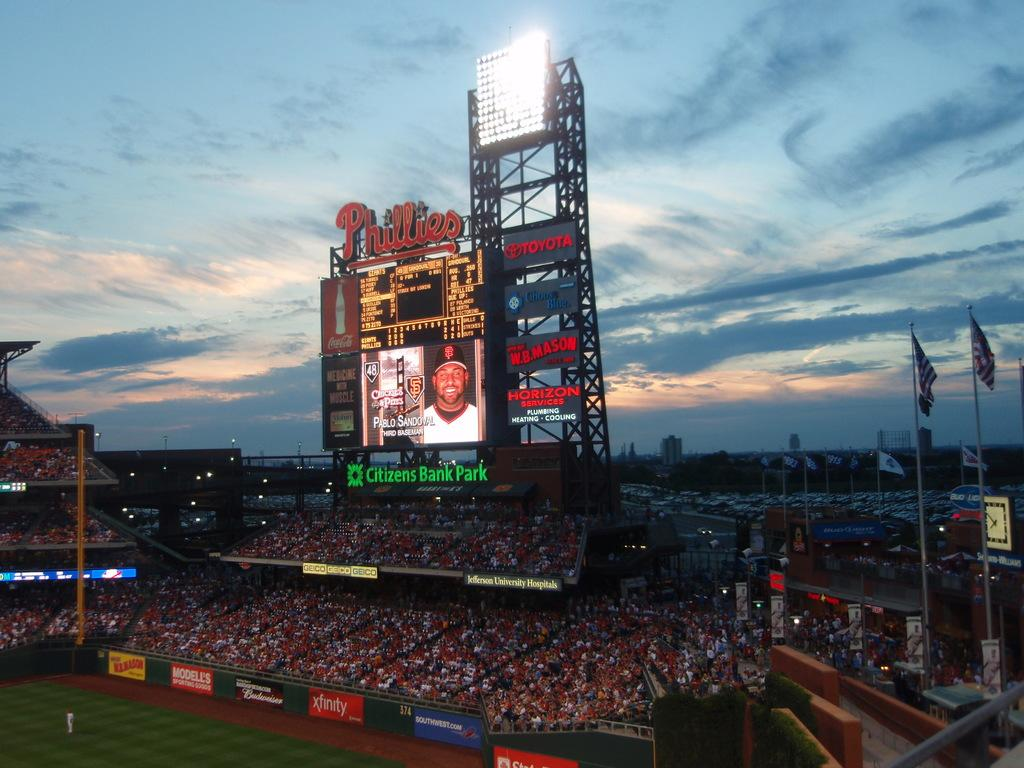<image>
Offer a succinct explanation of the picture presented. the crowd inside of the phillies baseball stadium 